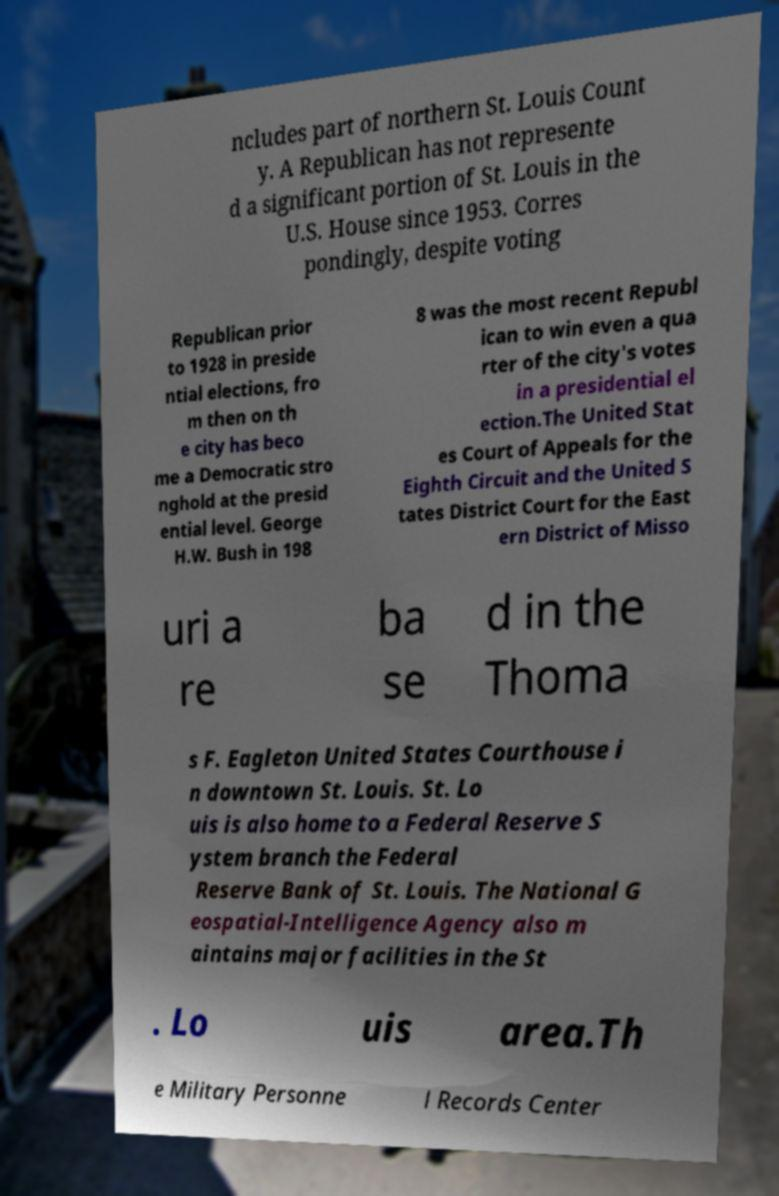Can you accurately transcribe the text from the provided image for me? ncludes part of northern St. Louis Count y. A Republican has not represente d a significant portion of St. Louis in the U.S. House since 1953. Corres pondingly, despite voting Republican prior to 1928 in preside ntial elections, fro m then on th e city has beco me a Democratic stro nghold at the presid ential level. George H.W. Bush in 198 8 was the most recent Republ ican to win even a qua rter of the city's votes in a presidential el ection.The United Stat es Court of Appeals for the Eighth Circuit and the United S tates District Court for the East ern District of Misso uri a re ba se d in the Thoma s F. Eagleton United States Courthouse i n downtown St. Louis. St. Lo uis is also home to a Federal Reserve S ystem branch the Federal Reserve Bank of St. Louis. The National G eospatial-Intelligence Agency also m aintains major facilities in the St . Lo uis area.Th e Military Personne l Records Center 